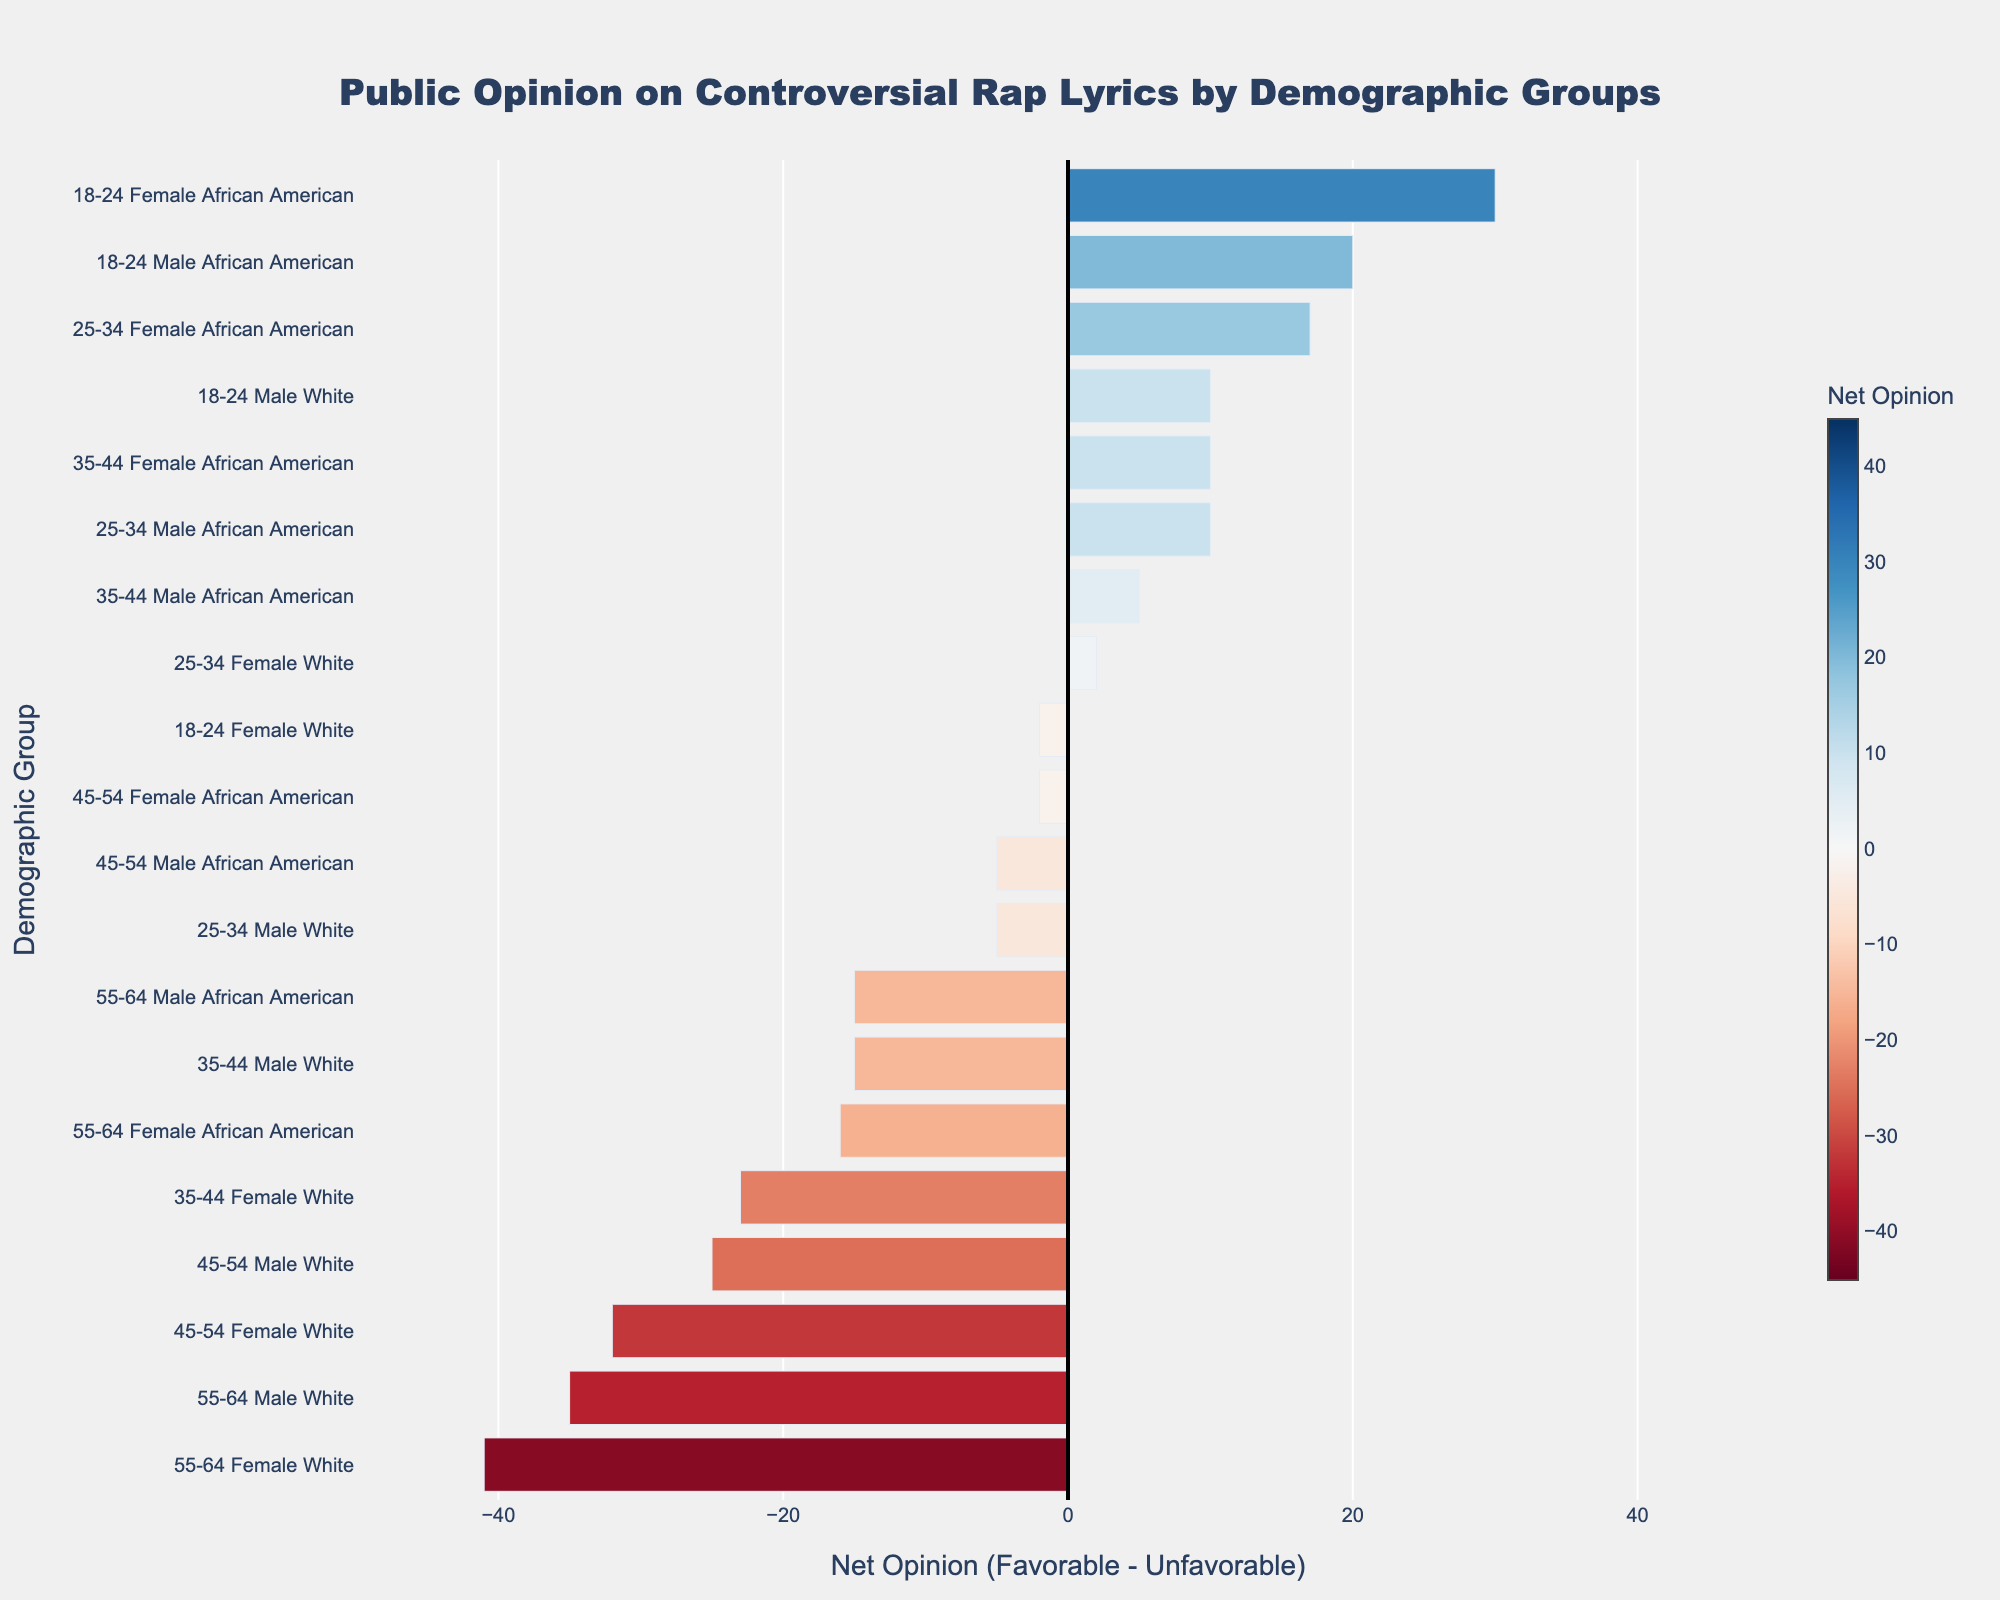Which demographic group has the most unfavorable opinion on controversial rap lyrics? Look at the bar with the lowest net opinion, which combines age, gender, and ethnicity. The one with the most negative value is less favorable. For example, the 55-64 Female White group.
Answer: 55-64 Female White Which demographic group has the most favorable opinion on controversial rap lyrics? Look at the bar with the highest net opinion, which combines age, gender, and ethnicity. The one with the most positive value is most favorable. For example, the 18-24 Female African American group.
Answer: 18-24 Female African American Among the 25-34 age group, which gender and ethnicity combination shows a more neutral opinion? Compare the neutral percentage for each gender and ethnicity within the 25-34 age group. For example, the Female White group has a neutral opinion of 18%.
Answer: Female White How does the net opinion of 35-44 Male White compare to that of 45-54 Male White? Locate the net opinion values (favorable - unfavorable) for both groups and compare them. The net opinion for 35-44 Male White is -15 and for 45-54 Male White is -25.
Answer: 35-44 Male White is higher Which gender in the 18-24 age group has a higher net opinion regardless of ethnicity? Check the net opinion for each gender irrespective of ethnicity in the 18-24 age group. For example, the net opinion of Male is positive, but Female African American is highest.
Answer: Female How does the net opinion for African Americans in the 45-54 age group compare to the overall average net opinion for African Americans across all age groups? Calculate net opinions: African Americans 45-54 Male is -5, and Female is -2. Calculate the overall average by summing the net opinions for all African American groups and dividing by their frequency.
Answer: 45-54 African American is lower than overall Which age group shows a notable decline in favorable opinion as age increases for the same gender and ethnicity? Track the net opinion trend from younger to older age groups for the same gender and ethnicity, such as for White Females, shown by a clear decline.
Answer: White Female In the African American demographic, which age group shows the smallest net loss or highest net gain in opinion? Compare the net opinion values for each age group in African Americans and identify the highest value or smallest loss. For example, the 18-24 Female group has the highest net gain.
Answer: 18-24 Female 